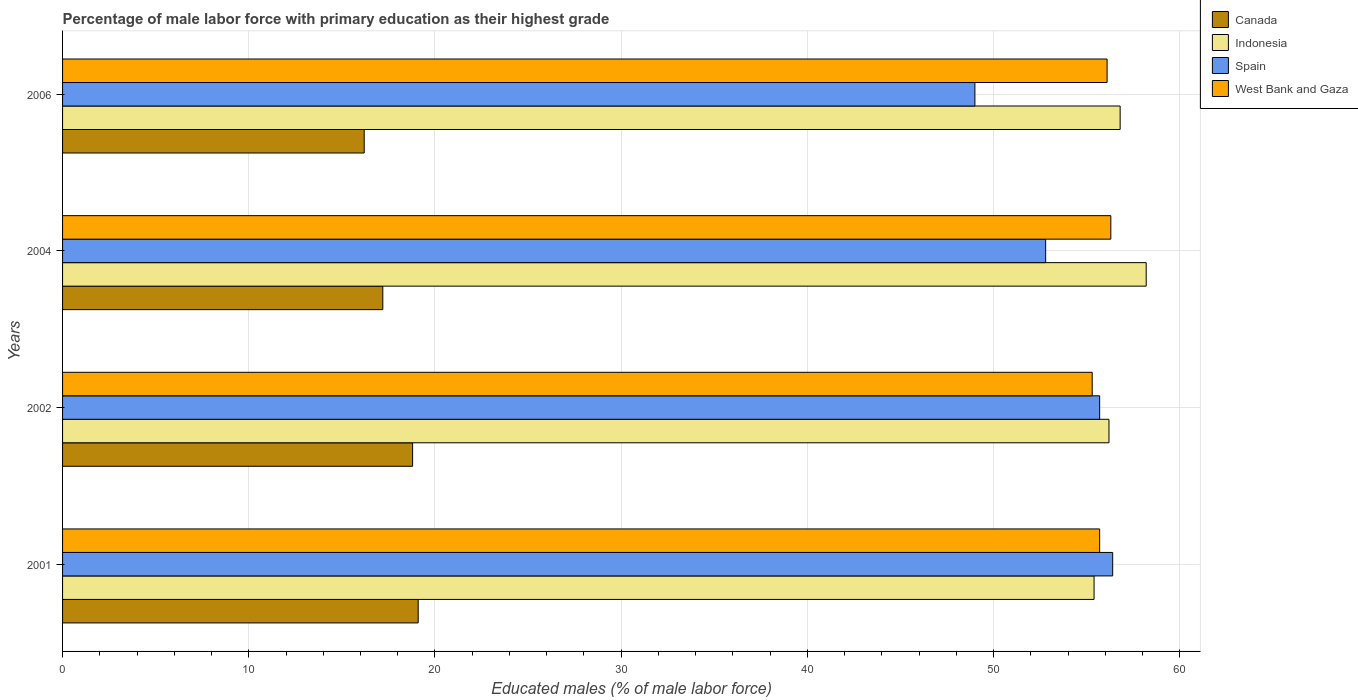Are the number of bars per tick equal to the number of legend labels?
Offer a very short reply. Yes. Are the number of bars on each tick of the Y-axis equal?
Offer a terse response. Yes. How many bars are there on the 3rd tick from the bottom?
Ensure brevity in your answer.  4. What is the label of the 4th group of bars from the top?
Provide a short and direct response. 2001. What is the percentage of male labor force with primary education in West Bank and Gaza in 2001?
Ensure brevity in your answer.  55.7. Across all years, what is the maximum percentage of male labor force with primary education in Canada?
Provide a succinct answer. 19.1. Across all years, what is the minimum percentage of male labor force with primary education in Indonesia?
Provide a succinct answer. 55.4. What is the total percentage of male labor force with primary education in Spain in the graph?
Offer a very short reply. 213.9. What is the difference between the percentage of male labor force with primary education in Canada in 2001 and that in 2006?
Offer a very short reply. 2.9. What is the difference between the percentage of male labor force with primary education in West Bank and Gaza in 2001 and the percentage of male labor force with primary education in Canada in 2002?
Your answer should be compact. 36.9. What is the average percentage of male labor force with primary education in West Bank and Gaza per year?
Give a very brief answer. 55.85. In the year 2004, what is the difference between the percentage of male labor force with primary education in Spain and percentage of male labor force with primary education in Canada?
Keep it short and to the point. 35.6. In how many years, is the percentage of male labor force with primary education in Canada greater than 44 %?
Your answer should be compact. 0. What is the ratio of the percentage of male labor force with primary education in West Bank and Gaza in 2001 to that in 2006?
Offer a terse response. 0.99. Is the percentage of male labor force with primary education in Spain in 2004 less than that in 2006?
Provide a short and direct response. No. What is the difference between the highest and the second highest percentage of male labor force with primary education in Canada?
Keep it short and to the point. 0.3. What is the difference between the highest and the lowest percentage of male labor force with primary education in Indonesia?
Provide a succinct answer. 2.8. In how many years, is the percentage of male labor force with primary education in West Bank and Gaza greater than the average percentage of male labor force with primary education in West Bank and Gaza taken over all years?
Offer a terse response. 2. Is the sum of the percentage of male labor force with primary education in Indonesia in 2004 and 2006 greater than the maximum percentage of male labor force with primary education in Spain across all years?
Provide a short and direct response. Yes. Is it the case that in every year, the sum of the percentage of male labor force with primary education in West Bank and Gaza and percentage of male labor force with primary education in Spain is greater than the sum of percentage of male labor force with primary education in Canada and percentage of male labor force with primary education in Indonesia?
Keep it short and to the point. Yes. What does the 4th bar from the top in 2002 represents?
Provide a succinct answer. Canada. How many bars are there?
Make the answer very short. 16. Are all the bars in the graph horizontal?
Offer a terse response. Yes. How many years are there in the graph?
Your answer should be very brief. 4. Are the values on the major ticks of X-axis written in scientific E-notation?
Keep it short and to the point. No. Does the graph contain any zero values?
Your response must be concise. No. Where does the legend appear in the graph?
Make the answer very short. Top right. What is the title of the graph?
Provide a succinct answer. Percentage of male labor force with primary education as their highest grade. What is the label or title of the X-axis?
Offer a terse response. Educated males (% of male labor force). What is the Educated males (% of male labor force) in Canada in 2001?
Offer a very short reply. 19.1. What is the Educated males (% of male labor force) of Indonesia in 2001?
Provide a succinct answer. 55.4. What is the Educated males (% of male labor force) of Spain in 2001?
Offer a very short reply. 56.4. What is the Educated males (% of male labor force) in West Bank and Gaza in 2001?
Keep it short and to the point. 55.7. What is the Educated males (% of male labor force) in Canada in 2002?
Keep it short and to the point. 18.8. What is the Educated males (% of male labor force) in Indonesia in 2002?
Make the answer very short. 56.2. What is the Educated males (% of male labor force) in Spain in 2002?
Make the answer very short. 55.7. What is the Educated males (% of male labor force) of West Bank and Gaza in 2002?
Offer a terse response. 55.3. What is the Educated males (% of male labor force) of Canada in 2004?
Ensure brevity in your answer.  17.2. What is the Educated males (% of male labor force) of Indonesia in 2004?
Your response must be concise. 58.2. What is the Educated males (% of male labor force) in Spain in 2004?
Keep it short and to the point. 52.8. What is the Educated males (% of male labor force) of West Bank and Gaza in 2004?
Provide a short and direct response. 56.3. What is the Educated males (% of male labor force) of Canada in 2006?
Offer a very short reply. 16.2. What is the Educated males (% of male labor force) in Indonesia in 2006?
Your answer should be very brief. 56.8. What is the Educated males (% of male labor force) of Spain in 2006?
Your answer should be very brief. 49. What is the Educated males (% of male labor force) of West Bank and Gaza in 2006?
Give a very brief answer. 56.1. Across all years, what is the maximum Educated males (% of male labor force) in Canada?
Provide a short and direct response. 19.1. Across all years, what is the maximum Educated males (% of male labor force) of Indonesia?
Keep it short and to the point. 58.2. Across all years, what is the maximum Educated males (% of male labor force) of Spain?
Give a very brief answer. 56.4. Across all years, what is the maximum Educated males (% of male labor force) of West Bank and Gaza?
Offer a terse response. 56.3. Across all years, what is the minimum Educated males (% of male labor force) of Canada?
Provide a short and direct response. 16.2. Across all years, what is the minimum Educated males (% of male labor force) in Indonesia?
Give a very brief answer. 55.4. Across all years, what is the minimum Educated males (% of male labor force) in West Bank and Gaza?
Your answer should be compact. 55.3. What is the total Educated males (% of male labor force) of Canada in the graph?
Give a very brief answer. 71.3. What is the total Educated males (% of male labor force) in Indonesia in the graph?
Offer a terse response. 226.6. What is the total Educated males (% of male labor force) of Spain in the graph?
Provide a short and direct response. 213.9. What is the total Educated males (% of male labor force) of West Bank and Gaza in the graph?
Ensure brevity in your answer.  223.4. What is the difference between the Educated males (% of male labor force) in Indonesia in 2001 and that in 2002?
Your answer should be very brief. -0.8. What is the difference between the Educated males (% of male labor force) of Spain in 2001 and that in 2002?
Your response must be concise. 0.7. What is the difference between the Educated males (% of male labor force) of West Bank and Gaza in 2001 and that in 2002?
Your answer should be very brief. 0.4. What is the difference between the Educated males (% of male labor force) of Canada in 2001 and that in 2004?
Offer a terse response. 1.9. What is the difference between the Educated males (% of male labor force) in Spain in 2001 and that in 2004?
Give a very brief answer. 3.6. What is the difference between the Educated males (% of male labor force) of West Bank and Gaza in 2001 and that in 2004?
Your response must be concise. -0.6. What is the difference between the Educated males (% of male labor force) of Indonesia in 2001 and that in 2006?
Offer a very short reply. -1.4. What is the difference between the Educated males (% of male labor force) in West Bank and Gaza in 2001 and that in 2006?
Your answer should be compact. -0.4. What is the difference between the Educated males (% of male labor force) in Indonesia in 2002 and that in 2004?
Make the answer very short. -2. What is the difference between the Educated males (% of male labor force) of Spain in 2002 and that in 2004?
Provide a short and direct response. 2.9. What is the difference between the Educated males (% of male labor force) in West Bank and Gaza in 2002 and that in 2006?
Provide a succinct answer. -0.8. What is the difference between the Educated males (% of male labor force) in Indonesia in 2004 and that in 2006?
Offer a terse response. 1.4. What is the difference between the Educated males (% of male labor force) in Spain in 2004 and that in 2006?
Make the answer very short. 3.8. What is the difference between the Educated males (% of male labor force) in West Bank and Gaza in 2004 and that in 2006?
Keep it short and to the point. 0.2. What is the difference between the Educated males (% of male labor force) in Canada in 2001 and the Educated males (% of male labor force) in Indonesia in 2002?
Provide a succinct answer. -37.1. What is the difference between the Educated males (% of male labor force) of Canada in 2001 and the Educated males (% of male labor force) of Spain in 2002?
Make the answer very short. -36.6. What is the difference between the Educated males (% of male labor force) of Canada in 2001 and the Educated males (% of male labor force) of West Bank and Gaza in 2002?
Ensure brevity in your answer.  -36.2. What is the difference between the Educated males (% of male labor force) in Indonesia in 2001 and the Educated males (% of male labor force) in West Bank and Gaza in 2002?
Give a very brief answer. 0.1. What is the difference between the Educated males (% of male labor force) of Canada in 2001 and the Educated males (% of male labor force) of Indonesia in 2004?
Provide a succinct answer. -39.1. What is the difference between the Educated males (% of male labor force) in Canada in 2001 and the Educated males (% of male labor force) in Spain in 2004?
Make the answer very short. -33.7. What is the difference between the Educated males (% of male labor force) of Canada in 2001 and the Educated males (% of male labor force) of West Bank and Gaza in 2004?
Provide a succinct answer. -37.2. What is the difference between the Educated males (% of male labor force) in Indonesia in 2001 and the Educated males (% of male labor force) in Spain in 2004?
Your answer should be very brief. 2.6. What is the difference between the Educated males (% of male labor force) of Indonesia in 2001 and the Educated males (% of male labor force) of West Bank and Gaza in 2004?
Give a very brief answer. -0.9. What is the difference between the Educated males (% of male labor force) in Canada in 2001 and the Educated males (% of male labor force) in Indonesia in 2006?
Offer a terse response. -37.7. What is the difference between the Educated males (% of male labor force) in Canada in 2001 and the Educated males (% of male labor force) in Spain in 2006?
Provide a short and direct response. -29.9. What is the difference between the Educated males (% of male labor force) in Canada in 2001 and the Educated males (% of male labor force) in West Bank and Gaza in 2006?
Provide a succinct answer. -37. What is the difference between the Educated males (% of male labor force) of Indonesia in 2001 and the Educated males (% of male labor force) of West Bank and Gaza in 2006?
Your answer should be compact. -0.7. What is the difference between the Educated males (% of male labor force) in Canada in 2002 and the Educated males (% of male labor force) in Indonesia in 2004?
Your answer should be very brief. -39.4. What is the difference between the Educated males (% of male labor force) in Canada in 2002 and the Educated males (% of male labor force) in Spain in 2004?
Offer a terse response. -34. What is the difference between the Educated males (% of male labor force) of Canada in 2002 and the Educated males (% of male labor force) of West Bank and Gaza in 2004?
Offer a very short reply. -37.5. What is the difference between the Educated males (% of male labor force) in Indonesia in 2002 and the Educated males (% of male labor force) in West Bank and Gaza in 2004?
Your answer should be very brief. -0.1. What is the difference between the Educated males (% of male labor force) in Spain in 2002 and the Educated males (% of male labor force) in West Bank and Gaza in 2004?
Provide a short and direct response. -0.6. What is the difference between the Educated males (% of male labor force) in Canada in 2002 and the Educated males (% of male labor force) in Indonesia in 2006?
Offer a terse response. -38. What is the difference between the Educated males (% of male labor force) of Canada in 2002 and the Educated males (% of male labor force) of Spain in 2006?
Your answer should be compact. -30.2. What is the difference between the Educated males (% of male labor force) of Canada in 2002 and the Educated males (% of male labor force) of West Bank and Gaza in 2006?
Keep it short and to the point. -37.3. What is the difference between the Educated males (% of male labor force) of Canada in 2004 and the Educated males (% of male labor force) of Indonesia in 2006?
Make the answer very short. -39.6. What is the difference between the Educated males (% of male labor force) in Canada in 2004 and the Educated males (% of male labor force) in Spain in 2006?
Offer a very short reply. -31.8. What is the difference between the Educated males (% of male labor force) in Canada in 2004 and the Educated males (% of male labor force) in West Bank and Gaza in 2006?
Provide a short and direct response. -38.9. What is the difference between the Educated males (% of male labor force) of Indonesia in 2004 and the Educated males (% of male labor force) of West Bank and Gaza in 2006?
Keep it short and to the point. 2.1. What is the difference between the Educated males (% of male labor force) of Spain in 2004 and the Educated males (% of male labor force) of West Bank and Gaza in 2006?
Provide a short and direct response. -3.3. What is the average Educated males (% of male labor force) in Canada per year?
Provide a succinct answer. 17.82. What is the average Educated males (% of male labor force) in Indonesia per year?
Offer a terse response. 56.65. What is the average Educated males (% of male labor force) of Spain per year?
Provide a succinct answer. 53.48. What is the average Educated males (% of male labor force) of West Bank and Gaza per year?
Provide a short and direct response. 55.85. In the year 2001, what is the difference between the Educated males (% of male labor force) in Canada and Educated males (% of male labor force) in Indonesia?
Offer a very short reply. -36.3. In the year 2001, what is the difference between the Educated males (% of male labor force) in Canada and Educated males (% of male labor force) in Spain?
Your answer should be compact. -37.3. In the year 2001, what is the difference between the Educated males (% of male labor force) in Canada and Educated males (% of male labor force) in West Bank and Gaza?
Provide a succinct answer. -36.6. In the year 2001, what is the difference between the Educated males (% of male labor force) in Indonesia and Educated males (% of male labor force) in Spain?
Ensure brevity in your answer.  -1. In the year 2001, what is the difference between the Educated males (% of male labor force) in Spain and Educated males (% of male labor force) in West Bank and Gaza?
Offer a very short reply. 0.7. In the year 2002, what is the difference between the Educated males (% of male labor force) in Canada and Educated males (% of male labor force) in Indonesia?
Give a very brief answer. -37.4. In the year 2002, what is the difference between the Educated males (% of male labor force) of Canada and Educated males (% of male labor force) of Spain?
Give a very brief answer. -36.9. In the year 2002, what is the difference between the Educated males (% of male labor force) in Canada and Educated males (% of male labor force) in West Bank and Gaza?
Give a very brief answer. -36.5. In the year 2002, what is the difference between the Educated males (% of male labor force) of Indonesia and Educated males (% of male labor force) of Spain?
Your response must be concise. 0.5. In the year 2002, what is the difference between the Educated males (% of male labor force) of Indonesia and Educated males (% of male labor force) of West Bank and Gaza?
Ensure brevity in your answer.  0.9. In the year 2002, what is the difference between the Educated males (% of male labor force) of Spain and Educated males (% of male labor force) of West Bank and Gaza?
Provide a succinct answer. 0.4. In the year 2004, what is the difference between the Educated males (% of male labor force) of Canada and Educated males (% of male labor force) of Indonesia?
Provide a short and direct response. -41. In the year 2004, what is the difference between the Educated males (% of male labor force) of Canada and Educated males (% of male labor force) of Spain?
Ensure brevity in your answer.  -35.6. In the year 2004, what is the difference between the Educated males (% of male labor force) of Canada and Educated males (% of male labor force) of West Bank and Gaza?
Offer a terse response. -39.1. In the year 2004, what is the difference between the Educated males (% of male labor force) in Indonesia and Educated males (% of male labor force) in West Bank and Gaza?
Make the answer very short. 1.9. In the year 2004, what is the difference between the Educated males (% of male labor force) in Spain and Educated males (% of male labor force) in West Bank and Gaza?
Provide a short and direct response. -3.5. In the year 2006, what is the difference between the Educated males (% of male labor force) of Canada and Educated males (% of male labor force) of Indonesia?
Give a very brief answer. -40.6. In the year 2006, what is the difference between the Educated males (% of male labor force) in Canada and Educated males (% of male labor force) in Spain?
Provide a succinct answer. -32.8. In the year 2006, what is the difference between the Educated males (% of male labor force) in Canada and Educated males (% of male labor force) in West Bank and Gaza?
Keep it short and to the point. -39.9. What is the ratio of the Educated males (% of male labor force) in Indonesia in 2001 to that in 2002?
Keep it short and to the point. 0.99. What is the ratio of the Educated males (% of male labor force) of Spain in 2001 to that in 2002?
Ensure brevity in your answer.  1.01. What is the ratio of the Educated males (% of male labor force) of Canada in 2001 to that in 2004?
Keep it short and to the point. 1.11. What is the ratio of the Educated males (% of male labor force) of Indonesia in 2001 to that in 2004?
Ensure brevity in your answer.  0.95. What is the ratio of the Educated males (% of male labor force) in Spain in 2001 to that in 2004?
Keep it short and to the point. 1.07. What is the ratio of the Educated males (% of male labor force) in West Bank and Gaza in 2001 to that in 2004?
Your response must be concise. 0.99. What is the ratio of the Educated males (% of male labor force) in Canada in 2001 to that in 2006?
Provide a short and direct response. 1.18. What is the ratio of the Educated males (% of male labor force) of Indonesia in 2001 to that in 2006?
Keep it short and to the point. 0.98. What is the ratio of the Educated males (% of male labor force) of Spain in 2001 to that in 2006?
Make the answer very short. 1.15. What is the ratio of the Educated males (% of male labor force) of Canada in 2002 to that in 2004?
Ensure brevity in your answer.  1.09. What is the ratio of the Educated males (% of male labor force) in Indonesia in 2002 to that in 2004?
Your answer should be very brief. 0.97. What is the ratio of the Educated males (% of male labor force) of Spain in 2002 to that in 2004?
Your answer should be very brief. 1.05. What is the ratio of the Educated males (% of male labor force) of West Bank and Gaza in 2002 to that in 2004?
Offer a very short reply. 0.98. What is the ratio of the Educated males (% of male labor force) of Canada in 2002 to that in 2006?
Offer a very short reply. 1.16. What is the ratio of the Educated males (% of male labor force) in Spain in 2002 to that in 2006?
Your answer should be compact. 1.14. What is the ratio of the Educated males (% of male labor force) in West Bank and Gaza in 2002 to that in 2006?
Ensure brevity in your answer.  0.99. What is the ratio of the Educated males (% of male labor force) of Canada in 2004 to that in 2006?
Keep it short and to the point. 1.06. What is the ratio of the Educated males (% of male labor force) in Indonesia in 2004 to that in 2006?
Provide a succinct answer. 1.02. What is the ratio of the Educated males (% of male labor force) in Spain in 2004 to that in 2006?
Your response must be concise. 1.08. What is the difference between the highest and the second highest Educated males (% of male labor force) in West Bank and Gaza?
Your answer should be very brief. 0.2. What is the difference between the highest and the lowest Educated males (% of male labor force) of Indonesia?
Your answer should be very brief. 2.8. What is the difference between the highest and the lowest Educated males (% of male labor force) in Spain?
Keep it short and to the point. 7.4. What is the difference between the highest and the lowest Educated males (% of male labor force) in West Bank and Gaza?
Provide a short and direct response. 1. 